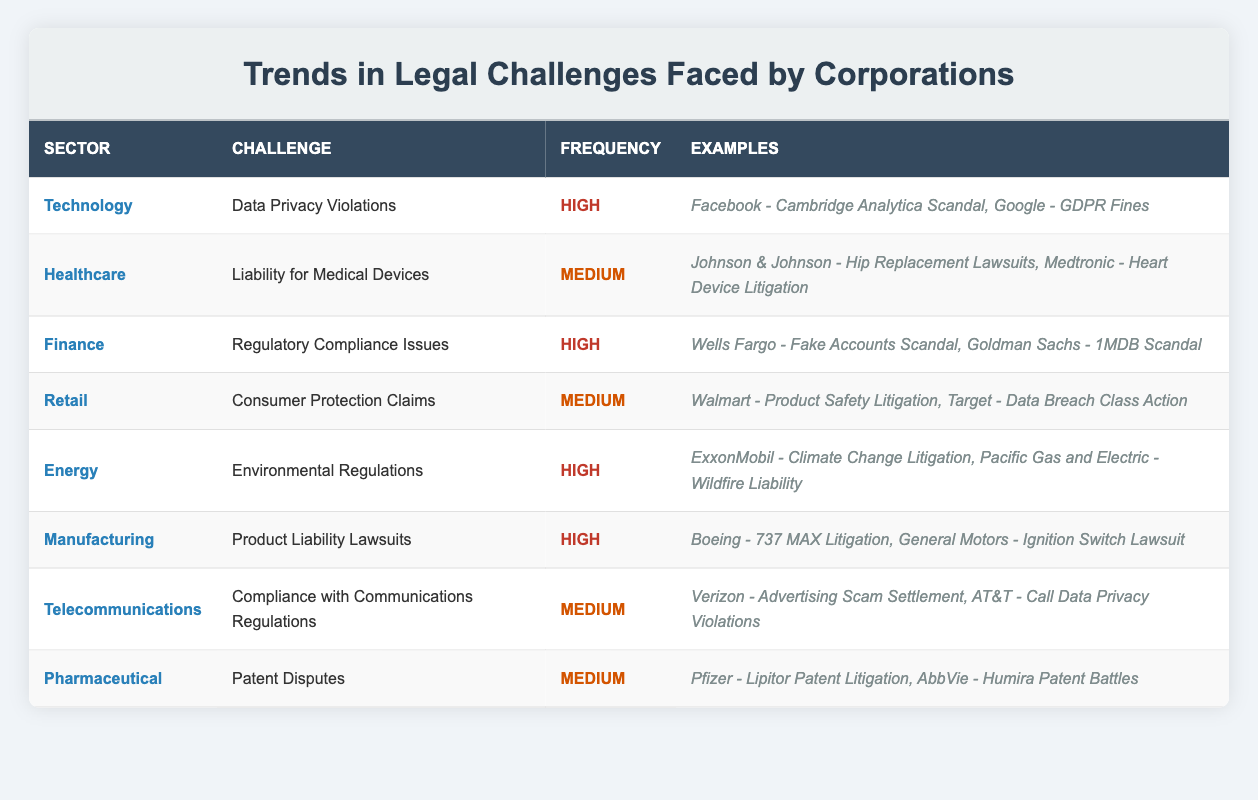What is the legal challenge faced by the Finance sector? The Finance sector faces the challenge of Regulatory Compliance Issues, as stated in the table.
Answer: Regulatory Compliance Issues Which sector has the highest frequency of legal challenges? The sectors Technology, Finance, Energy, and Manufacturing all have a high frequency of legal challenges as indicated in the table—this implies that out of the presented sectors, the term "highest frequency" applies to multiple entities.
Answer: Technology, Finance, Energy, Manufacturing How many sectors have medium frequency legal challenges? There are four sectors listed with medium frequency legal challenges: Healthcare, Retail, Telecommunications, and Pharmaceutical. Therefore, we can count these sectors to get the total number.
Answer: 4 True or False: The Healthcare sector faces challenges related to data privacy violations. According to the table, the Healthcare sector does not face data privacy violations; rather, it faces Liability for Medical Devices. Thus, the statement is false.
Answer: False Which two examples illustrate environmental regulations in the Energy sector? The examples provided for environmental regulations in the Energy sector are ExxonMobil - Climate Change Litigation and Pacific Gas and Electric - Wildfire Liability, as referenced in the table.
Answer: ExxonMobil - Climate Change Litigation, Pacific Gas and Electric - Wildfire Liability What is the average frequency of legal challenges across all sectors? The sectors with high frequency are Technology, Finance, Energy, and Manufacturing (4 sectors), while the ones with medium frequency are Healthcare, Retail, Telecommunications, and Pharmaceutical (4 sectors). So there are 4 high and 4 medium, making a total of 8. Since medium frequency is considered as 1 and high as 2, we have (4*2 + 4*1) / 8 = (8 + 4) / 8 = 12 / 8 = 1.5. The average frequency, when assigned appropriately, results in a value of 1.5.
Answer: 1.5 Which sector had a legal challenge related to product safety litigation? The Retail sector is noted for having a legal challenge related to Consumer Protection Claims, with product safety litigation mentioned as an example within that context in the table.
Answer: Retail Is it true that all sectors have high frequency legal challenges? The table shows that not all sectors have high-frequency challenges; sectors like Healthcare, Retail, Telecommunications, and Pharmaceutical only have medium frequency challenges. Thus, the statement is false.
Answer: False 